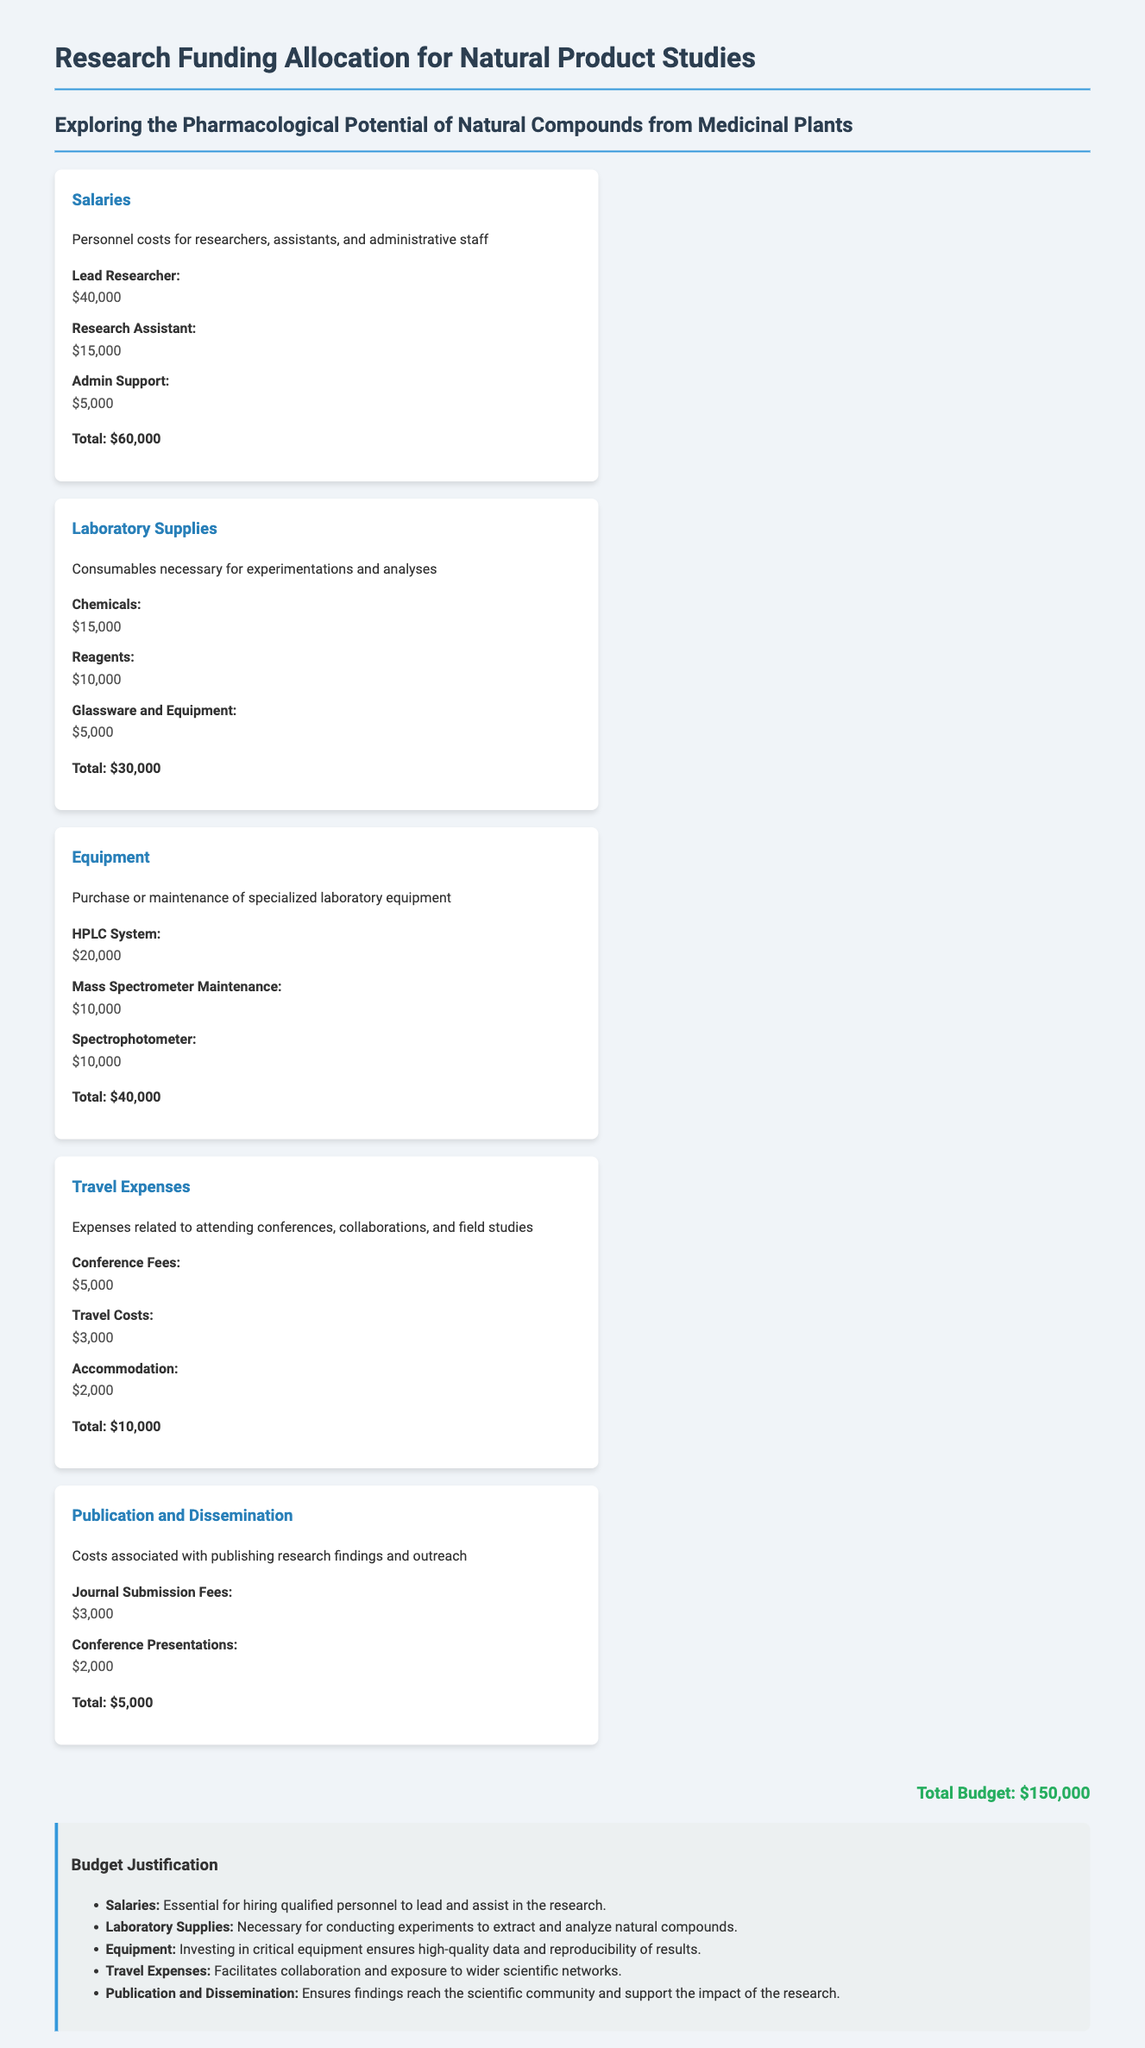What is the total budget? The total budget is stated at the bottom of the document.
Answer: $150,000 How much is allocated for salaries? The budget item specifically lists the total amount allocated for salaries.
Answer: $60,000 What are the total costs for laboratory supplies? The document outlines the expenses under laboratory supplies and provides a total.
Answer: $30,000 How much is budgeted for the HPLC system? The cost for the HPLC system is explicitly mentioned under the equipment section.
Answer: $20,000 What are the travel costs? The section on travel expenses lists its total amount.
Answer: $10,000 How many personnel are included in the salaries category? The salaries section details the personnel types, which include a lead researcher, research assistant, and admin support.
Answer: 3 What is the cost of journal submission fees? The document specifies the cost associated with journal submission in the publication and dissemination section.
Answer: $3,000 Why is investment in equipment emphasized? The justification section states the importance of investing in equipment for quality data collection.
Answer: High-quality data What are the total costs for publication and dissemination? The total for publication and dissemination is listed in that specific section of the budget.
Answer: $5,000 What type of expenses are included in travel expenses? The travel expenses section enumerates specific types of costs related to conferences and collaborations.
Answer: Conference Fees, Travel Costs, Accommodation 